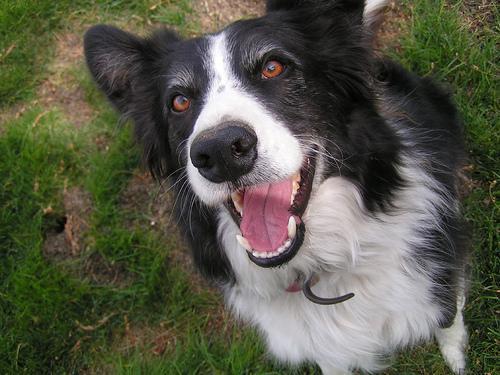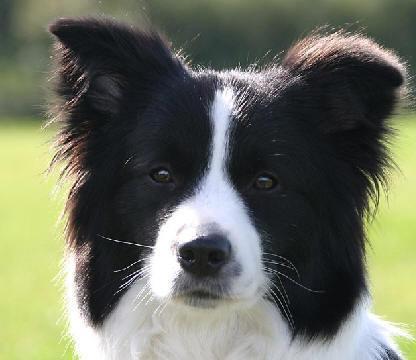The first image is the image on the left, the second image is the image on the right. Considering the images on both sides, is "A dog in one image has one white eye and one black eye." valid? Answer yes or no. No. 